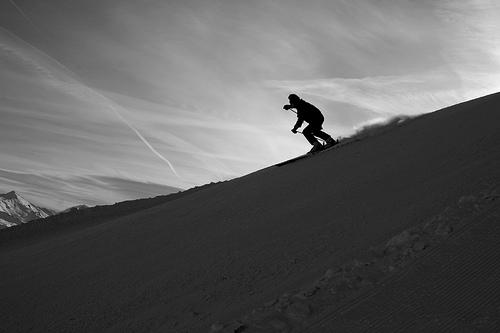What sport is this?
Write a very short answer. Skiing. Is this skier going down a hill or a mountain?
Keep it brief. Hill. Is this person snowboarding?
Concise answer only. Yes. 